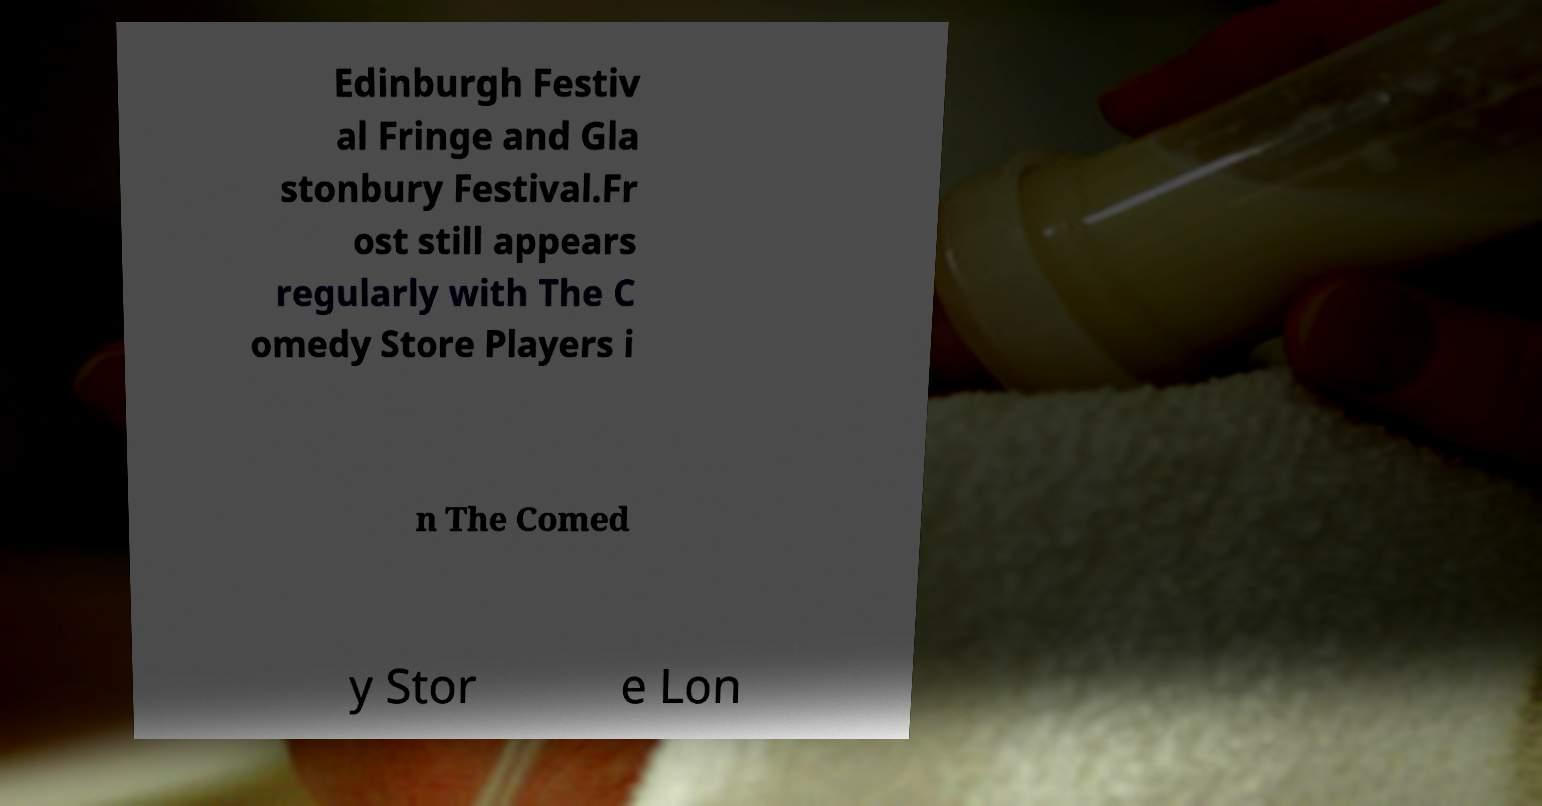Please identify and transcribe the text found in this image. Edinburgh Festiv al Fringe and Gla stonbury Festival.Fr ost still appears regularly with The C omedy Store Players i n The Comed y Stor e Lon 